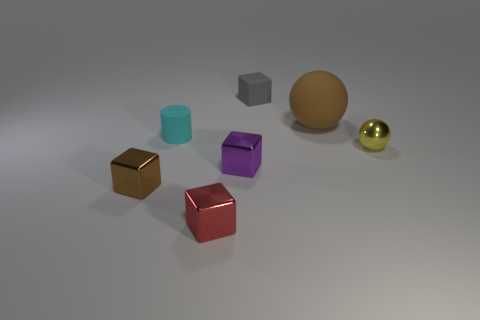How many things are either small purple objects or small metal things left of the tiny ball?
Keep it short and to the point. 3. Are there any matte cylinders of the same color as the large ball?
Provide a short and direct response. No. How many yellow objects are either metal cubes or large rubber cubes?
Offer a terse response. 0. How many other objects are there of the same size as the cyan object?
Offer a very short reply. 5. What number of big things are either yellow objects or shiny things?
Your answer should be compact. 0. There is a purple thing; is it the same size as the thing in front of the brown shiny cube?
Keep it short and to the point. Yes. What number of other objects are there of the same shape as the gray thing?
Keep it short and to the point. 3. The brown object that is the same material as the tiny cyan thing is what shape?
Your answer should be very brief. Sphere. Is there a tiny purple metallic block?
Offer a terse response. Yes. Is the number of small yellow shiny objects that are behind the red shiny cube less than the number of tiny matte blocks on the right side of the gray cube?
Your answer should be compact. No. 